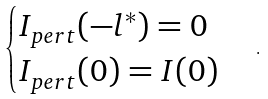<formula> <loc_0><loc_0><loc_500><loc_500>\begin{cases} I _ { p e r t } ( - l ^ { * } ) = 0 \\ I _ { p e r t } ( 0 ) = I ( 0 ) \end{cases} \, .</formula> 